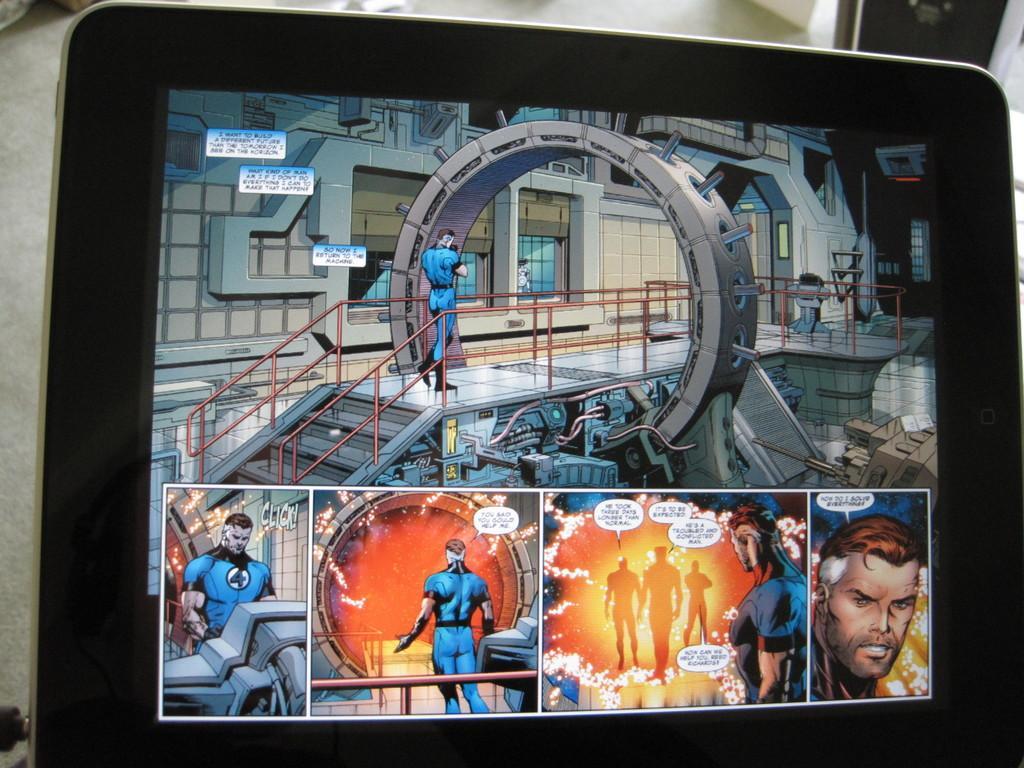Please provide a concise description of this image. In this image we can see a monitor screen with some images. 